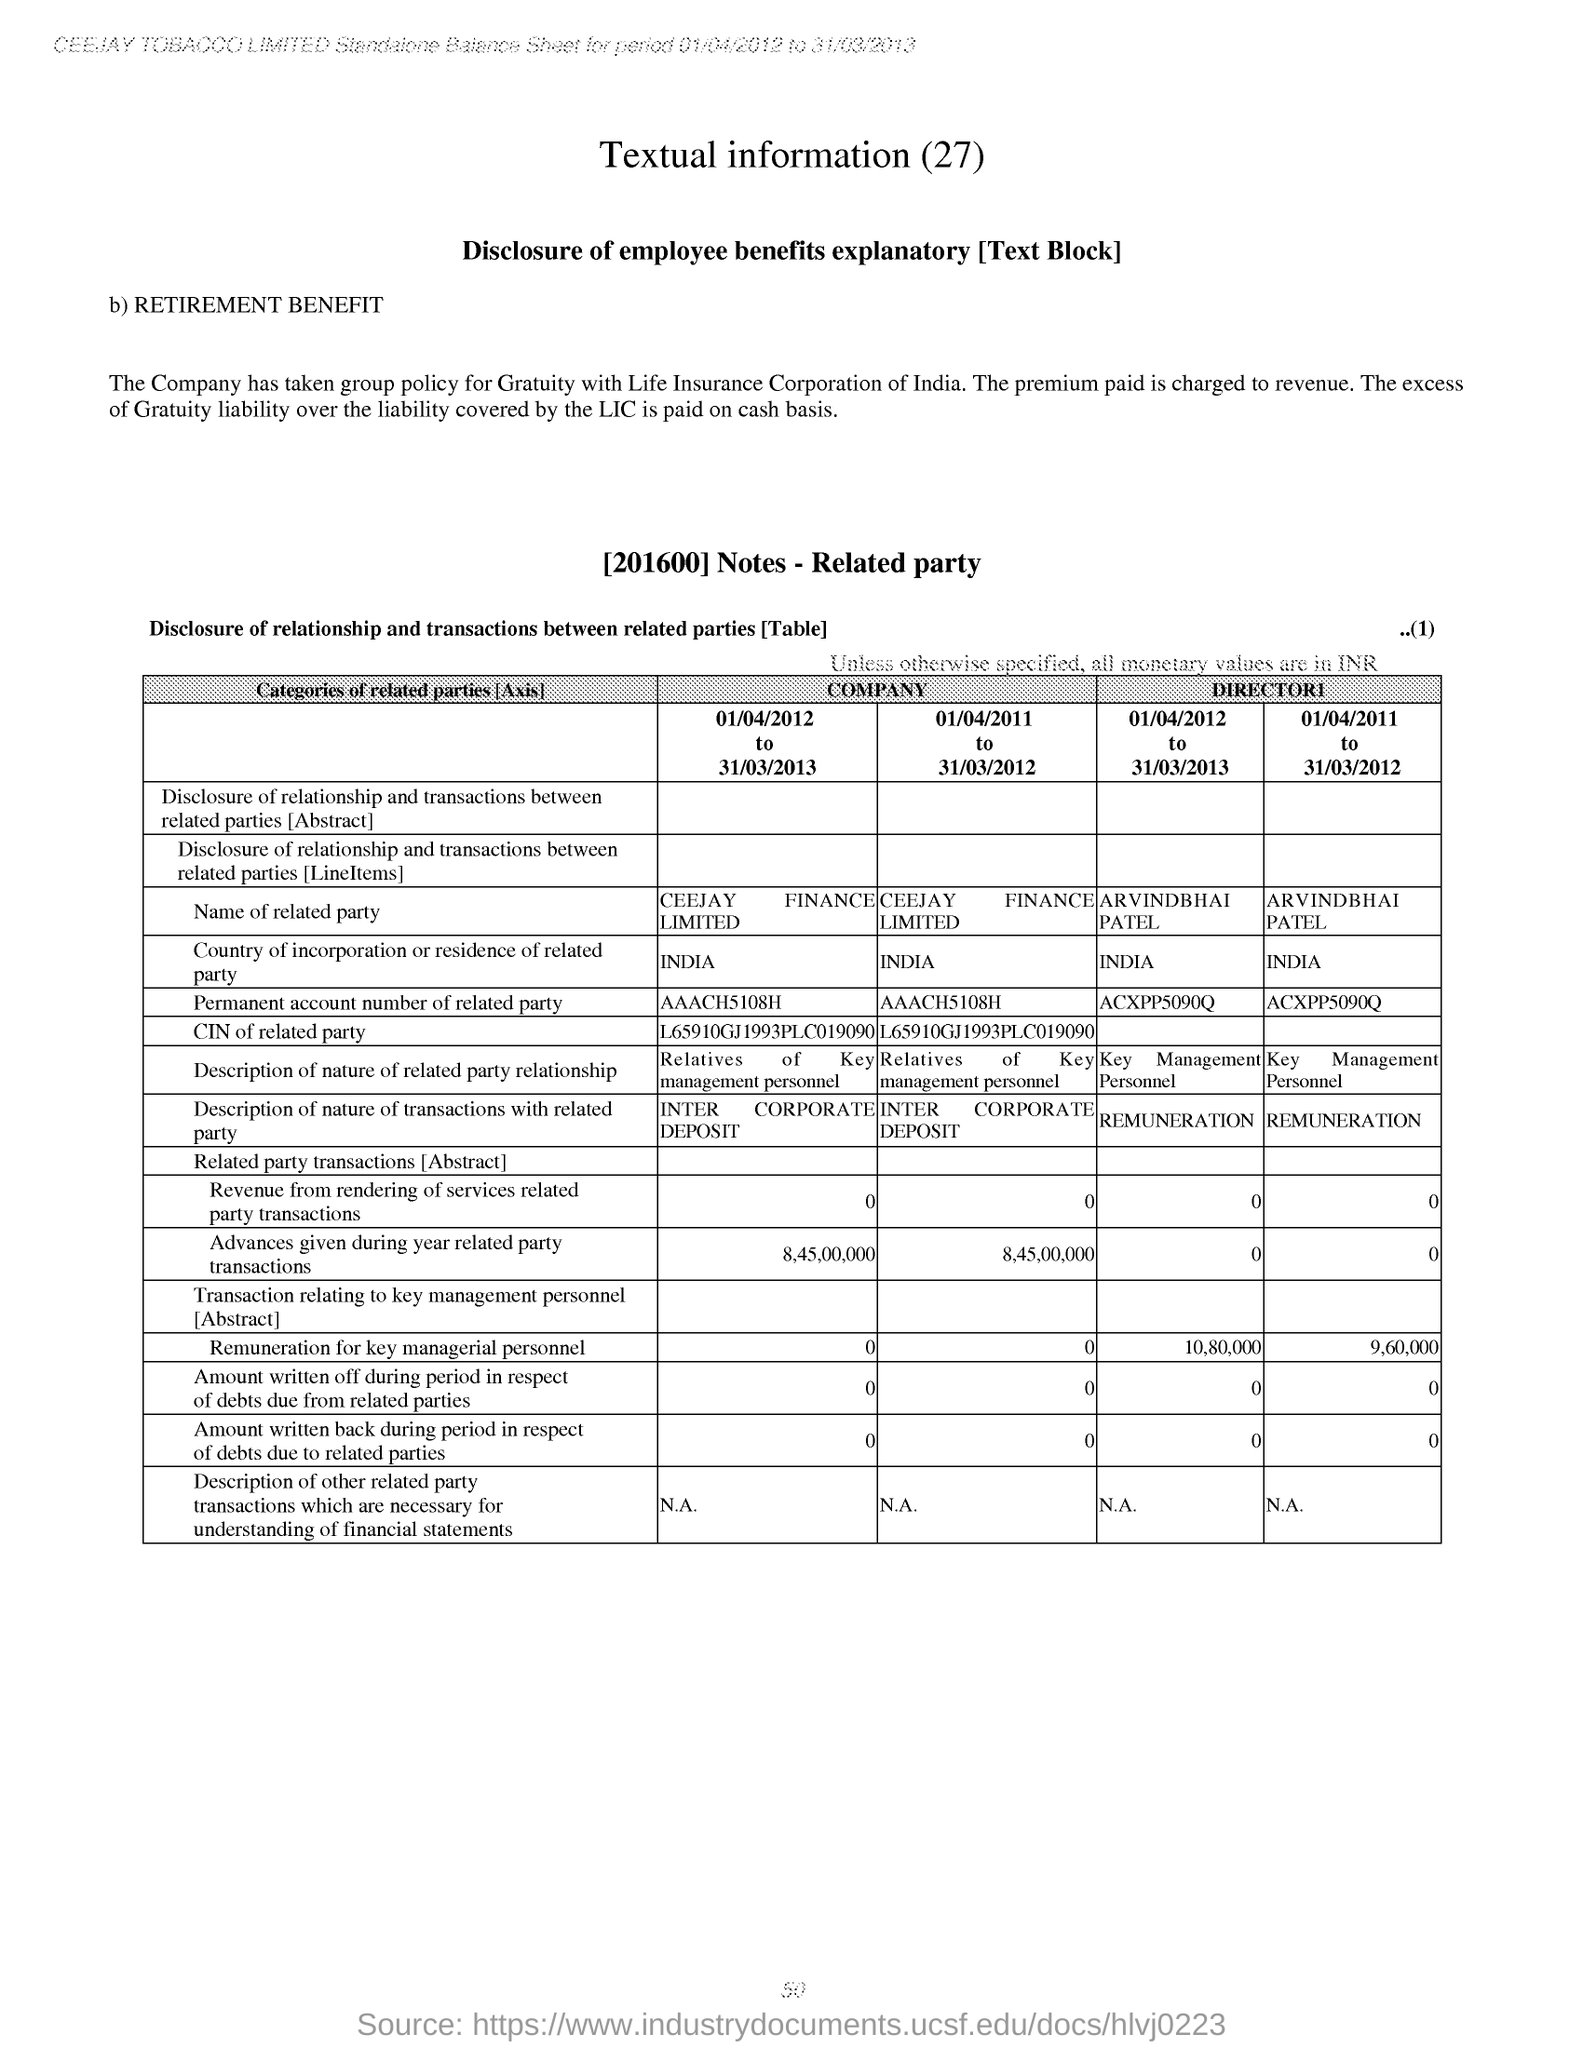What is the heading of the document?
Ensure brevity in your answer.  Textual information (27). 